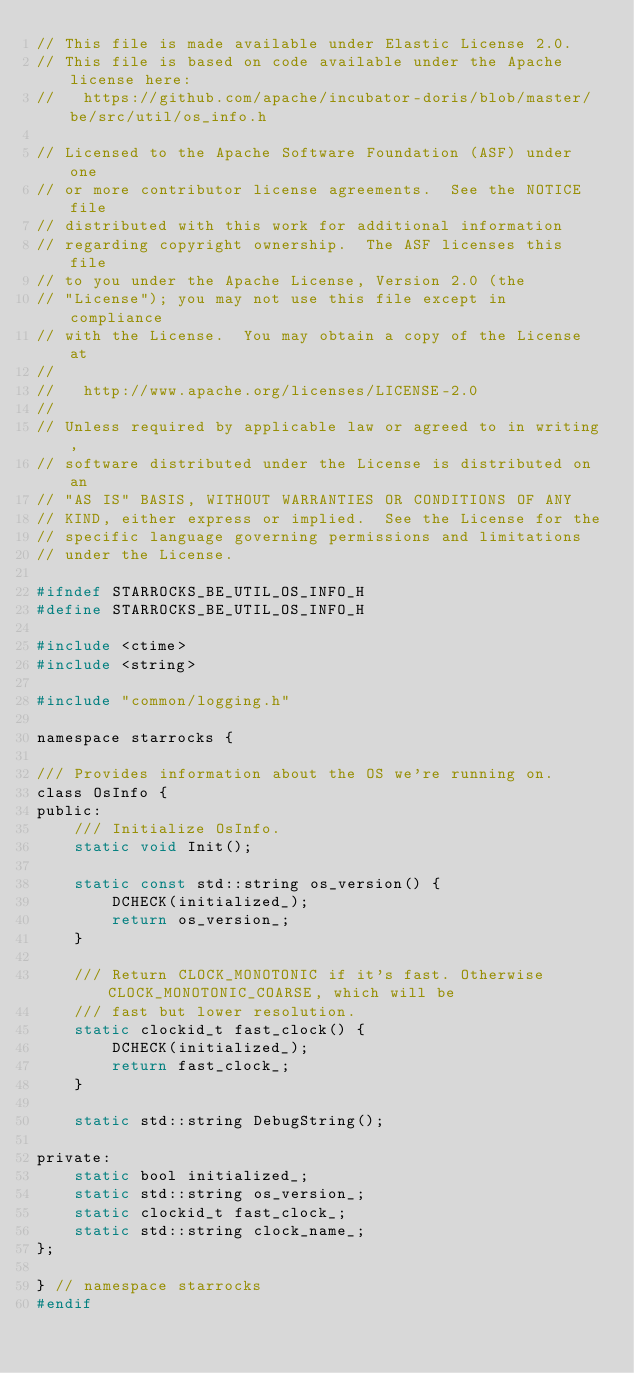Convert code to text. <code><loc_0><loc_0><loc_500><loc_500><_C_>// This file is made available under Elastic License 2.0.
// This file is based on code available under the Apache license here:
//   https://github.com/apache/incubator-doris/blob/master/be/src/util/os_info.h

// Licensed to the Apache Software Foundation (ASF) under one
// or more contributor license agreements.  See the NOTICE file
// distributed with this work for additional information
// regarding copyright ownership.  The ASF licenses this file
// to you under the Apache License, Version 2.0 (the
// "License"); you may not use this file except in compliance
// with the License.  You may obtain a copy of the License at
//
//   http://www.apache.org/licenses/LICENSE-2.0
//
// Unless required by applicable law or agreed to in writing,
// software distributed under the License is distributed on an
// "AS IS" BASIS, WITHOUT WARRANTIES OR CONDITIONS OF ANY
// KIND, either express or implied.  See the License for the
// specific language governing permissions and limitations
// under the License.

#ifndef STARROCKS_BE_UTIL_OS_INFO_H
#define STARROCKS_BE_UTIL_OS_INFO_H

#include <ctime>
#include <string>

#include "common/logging.h"

namespace starrocks {

/// Provides information about the OS we're running on.
class OsInfo {
public:
    /// Initialize OsInfo.
    static void Init();

    static const std::string os_version() {
        DCHECK(initialized_);
        return os_version_;
    }

    /// Return CLOCK_MONOTONIC if it's fast. Otherwise CLOCK_MONOTONIC_COARSE, which will be
    /// fast but lower resolution.
    static clockid_t fast_clock() {
        DCHECK(initialized_);
        return fast_clock_;
    }

    static std::string DebugString();

private:
    static bool initialized_;
    static std::string os_version_;
    static clockid_t fast_clock_;
    static std::string clock_name_;
};

} // namespace starrocks
#endif
</code> 